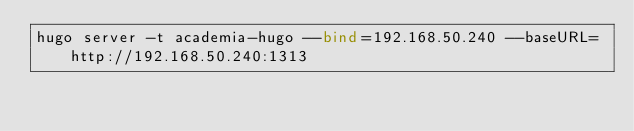Convert code to text. <code><loc_0><loc_0><loc_500><loc_500><_Bash_>hugo server -t academia-hugo --bind=192.168.50.240 --baseURL=http://192.168.50.240:1313
</code> 